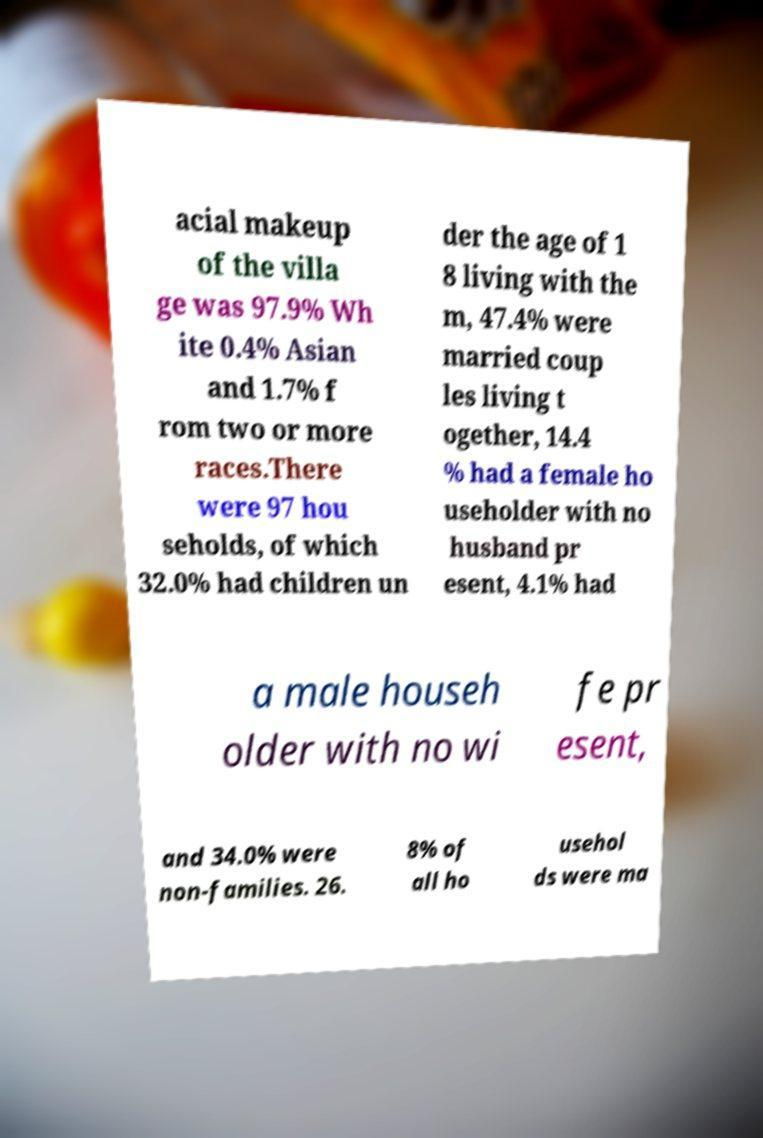Could you extract and type out the text from this image? acial makeup of the villa ge was 97.9% Wh ite 0.4% Asian and 1.7% f rom two or more races.There were 97 hou seholds, of which 32.0% had children un der the age of 1 8 living with the m, 47.4% were married coup les living t ogether, 14.4 % had a female ho useholder with no husband pr esent, 4.1% had a male househ older with no wi fe pr esent, and 34.0% were non-families. 26. 8% of all ho usehol ds were ma 